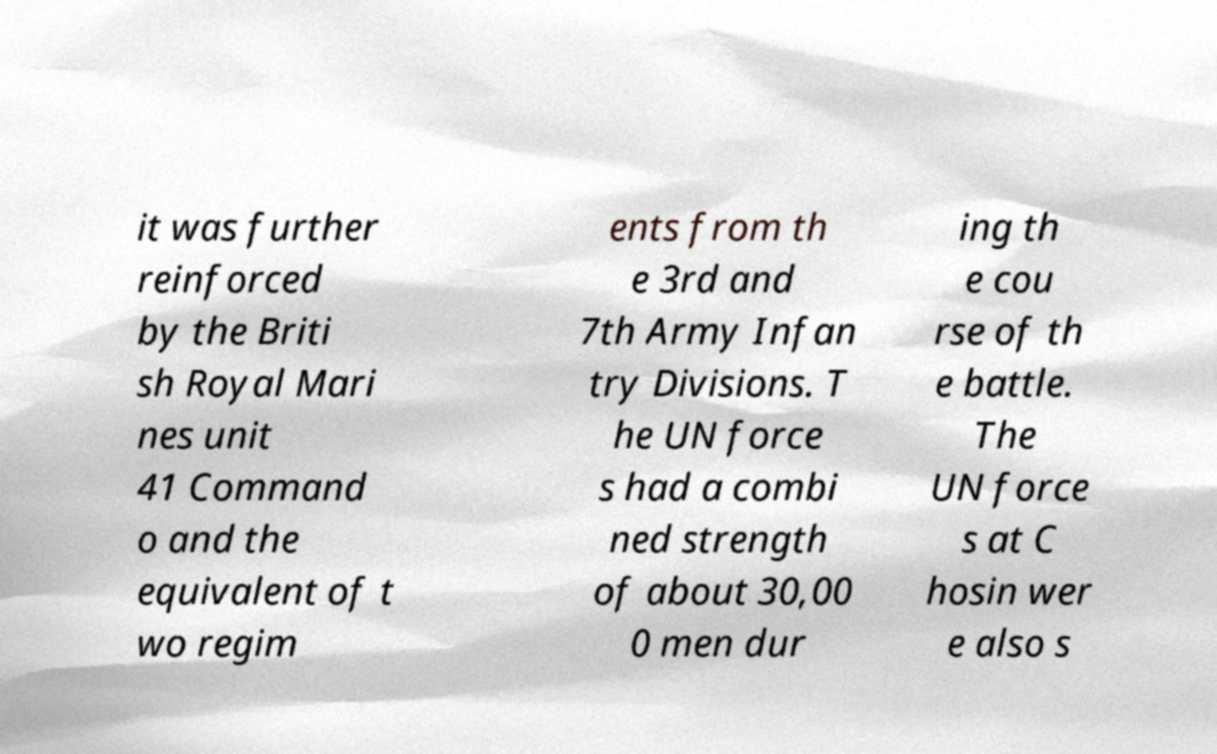Please read and relay the text visible in this image. What does it say? it was further reinforced by the Briti sh Royal Mari nes unit 41 Command o and the equivalent of t wo regim ents from th e 3rd and 7th Army Infan try Divisions. T he UN force s had a combi ned strength of about 30,00 0 men dur ing th e cou rse of th e battle. The UN force s at C hosin wer e also s 